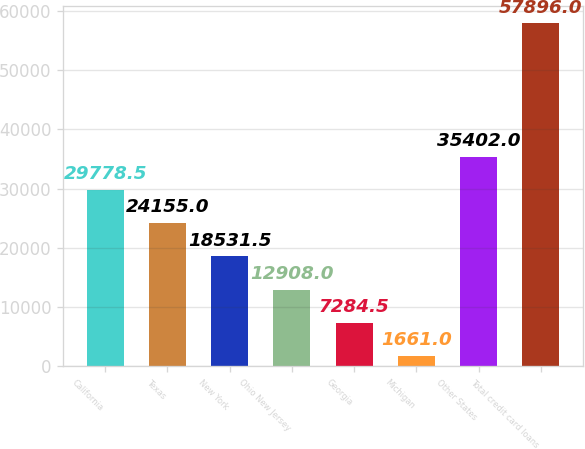Convert chart. <chart><loc_0><loc_0><loc_500><loc_500><bar_chart><fcel>California<fcel>Texas<fcel>New York<fcel>Ohio New Jersey<fcel>Georgia<fcel>Michigan<fcel>Other States<fcel>Total credit card loans<nl><fcel>29778.5<fcel>24155<fcel>18531.5<fcel>12908<fcel>7284.5<fcel>1661<fcel>35402<fcel>57896<nl></chart> 